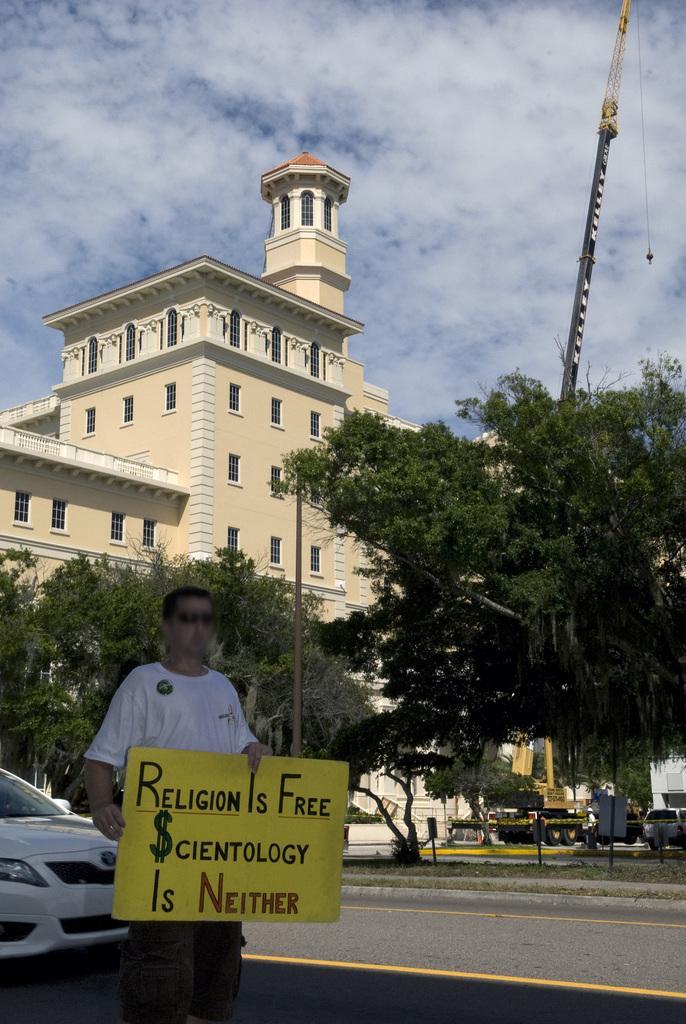Can you describe this image briefly? This picture is clicked outside. On the left there is a person wearing white color t-shirt, holding a banner and standing on the ground and we can see the text is written on the banner. On the left corner there is a car parked on the ground. In the center we can see the trees and some vehicles. In the background there is a sky which is full of clouds and we can see the metal stand and a building. 